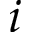Convert formula to latex. <formula><loc_0><loc_0><loc_500><loc_500>i</formula> 